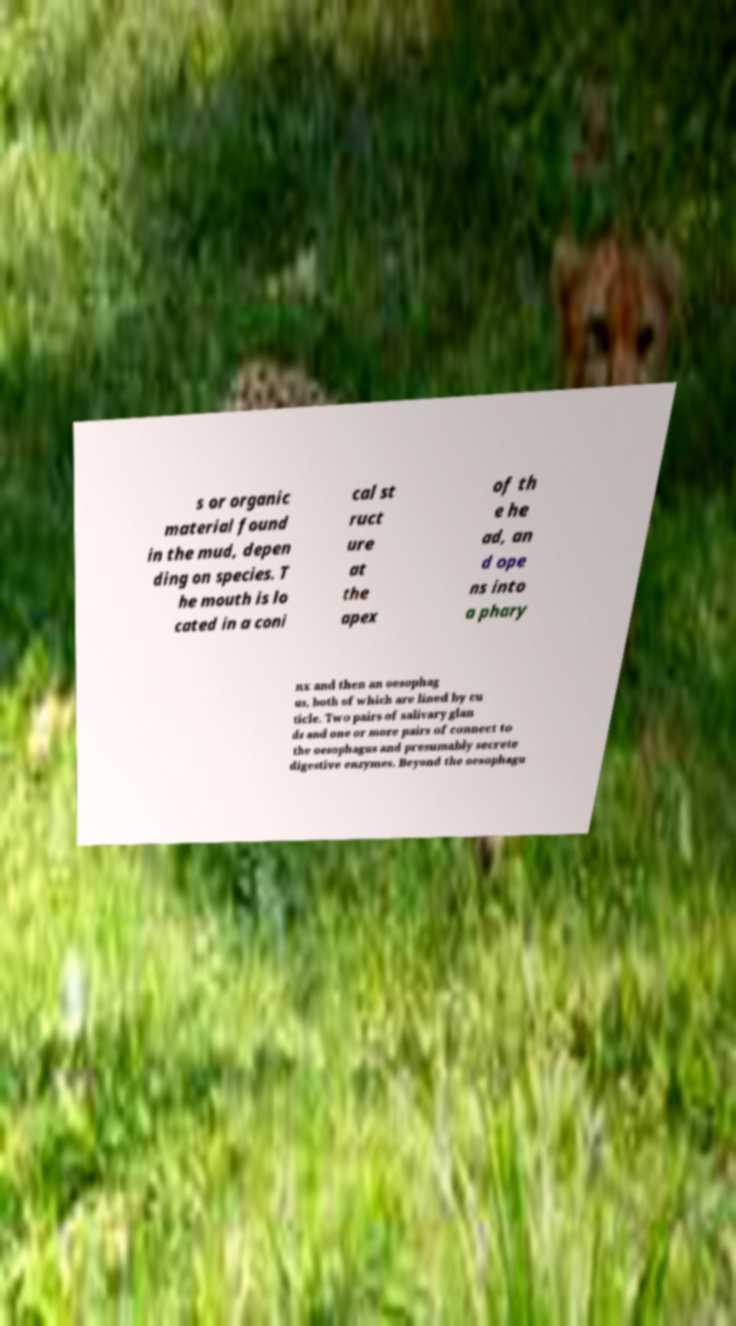Please identify and transcribe the text found in this image. s or organic material found in the mud, depen ding on species. T he mouth is lo cated in a coni cal st ruct ure at the apex of th e he ad, an d ope ns into a phary nx and then an oesophag us, both of which are lined by cu ticle. Two pairs of salivary glan ds and one or more pairs of connect to the oesophagus and presumably secrete digestive enzymes. Beyond the oesophagu 